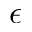<formula> <loc_0><loc_0><loc_500><loc_500>\epsilon</formula> 